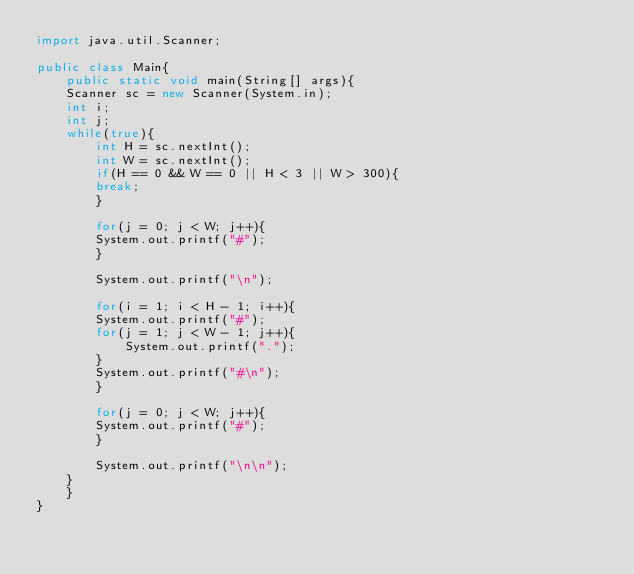Convert code to text. <code><loc_0><loc_0><loc_500><loc_500><_Java_>import java.util.Scanner;

public class Main{
    public static void main(String[] args){
	Scanner sc = new Scanner(System.in);
	int i;
	int j;
	while(true){
	    int H = sc.nextInt();
	    int W = sc.nextInt();
	    if(H == 0 && W == 0 || H < 3 || W > 300){
	    break;
	    }

	    for(j = 0; j < W; j++){
		System.out.printf("#");
	    }

	    System.out.printf("\n");

	    for(i = 1; i < H - 1; i++){
		System.out.printf("#");
		for(j = 1; j < W - 1; j++){
		    System.out.printf(".");
		}
		System.out.printf("#\n");
	    }

	    for(j = 0; j < W; j++){
		System.out.printf("#");
	    }

	    System.out.printf("\n\n");
	}
    }
}</code> 